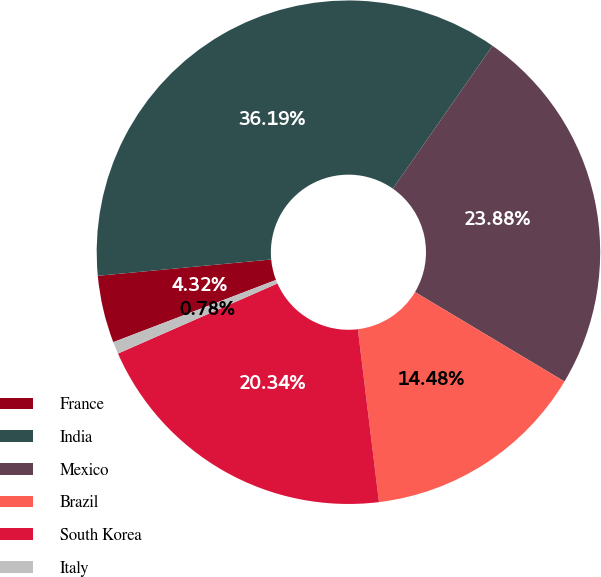Convert chart. <chart><loc_0><loc_0><loc_500><loc_500><pie_chart><fcel>France<fcel>India<fcel>Mexico<fcel>Brazil<fcel>South Korea<fcel>Italy<nl><fcel>4.32%<fcel>36.19%<fcel>23.88%<fcel>14.48%<fcel>20.34%<fcel>0.78%<nl></chart> 